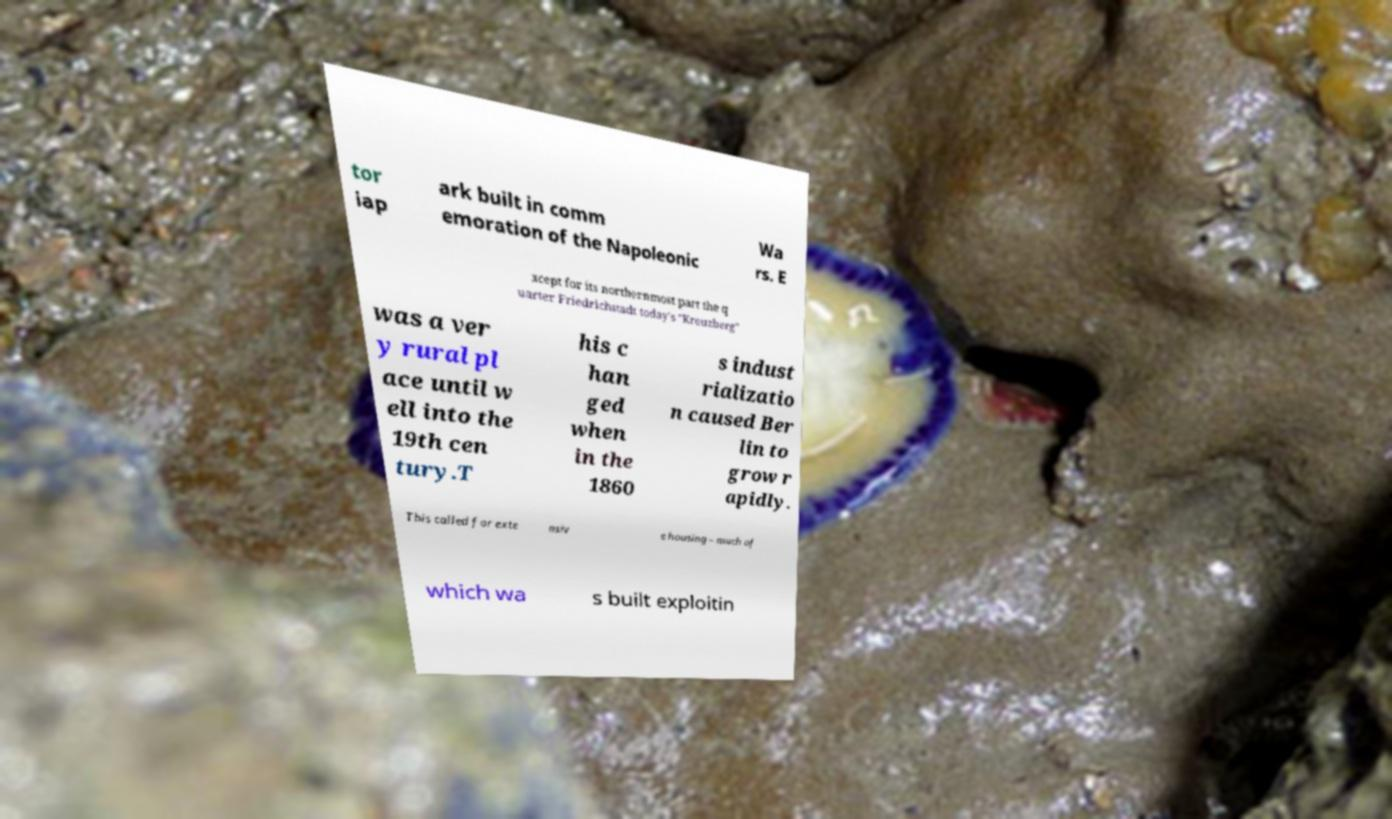Please read and relay the text visible in this image. What does it say? tor iap ark built in comm emoration of the Napoleonic Wa rs. E xcept for its northernmost part the q uarter Friedrichstadt today's "Kreuzberg" was a ver y rural pl ace until w ell into the 19th cen tury.T his c han ged when in the 1860 s indust rializatio n caused Ber lin to grow r apidly. This called for exte nsiv e housing – much of which wa s built exploitin 